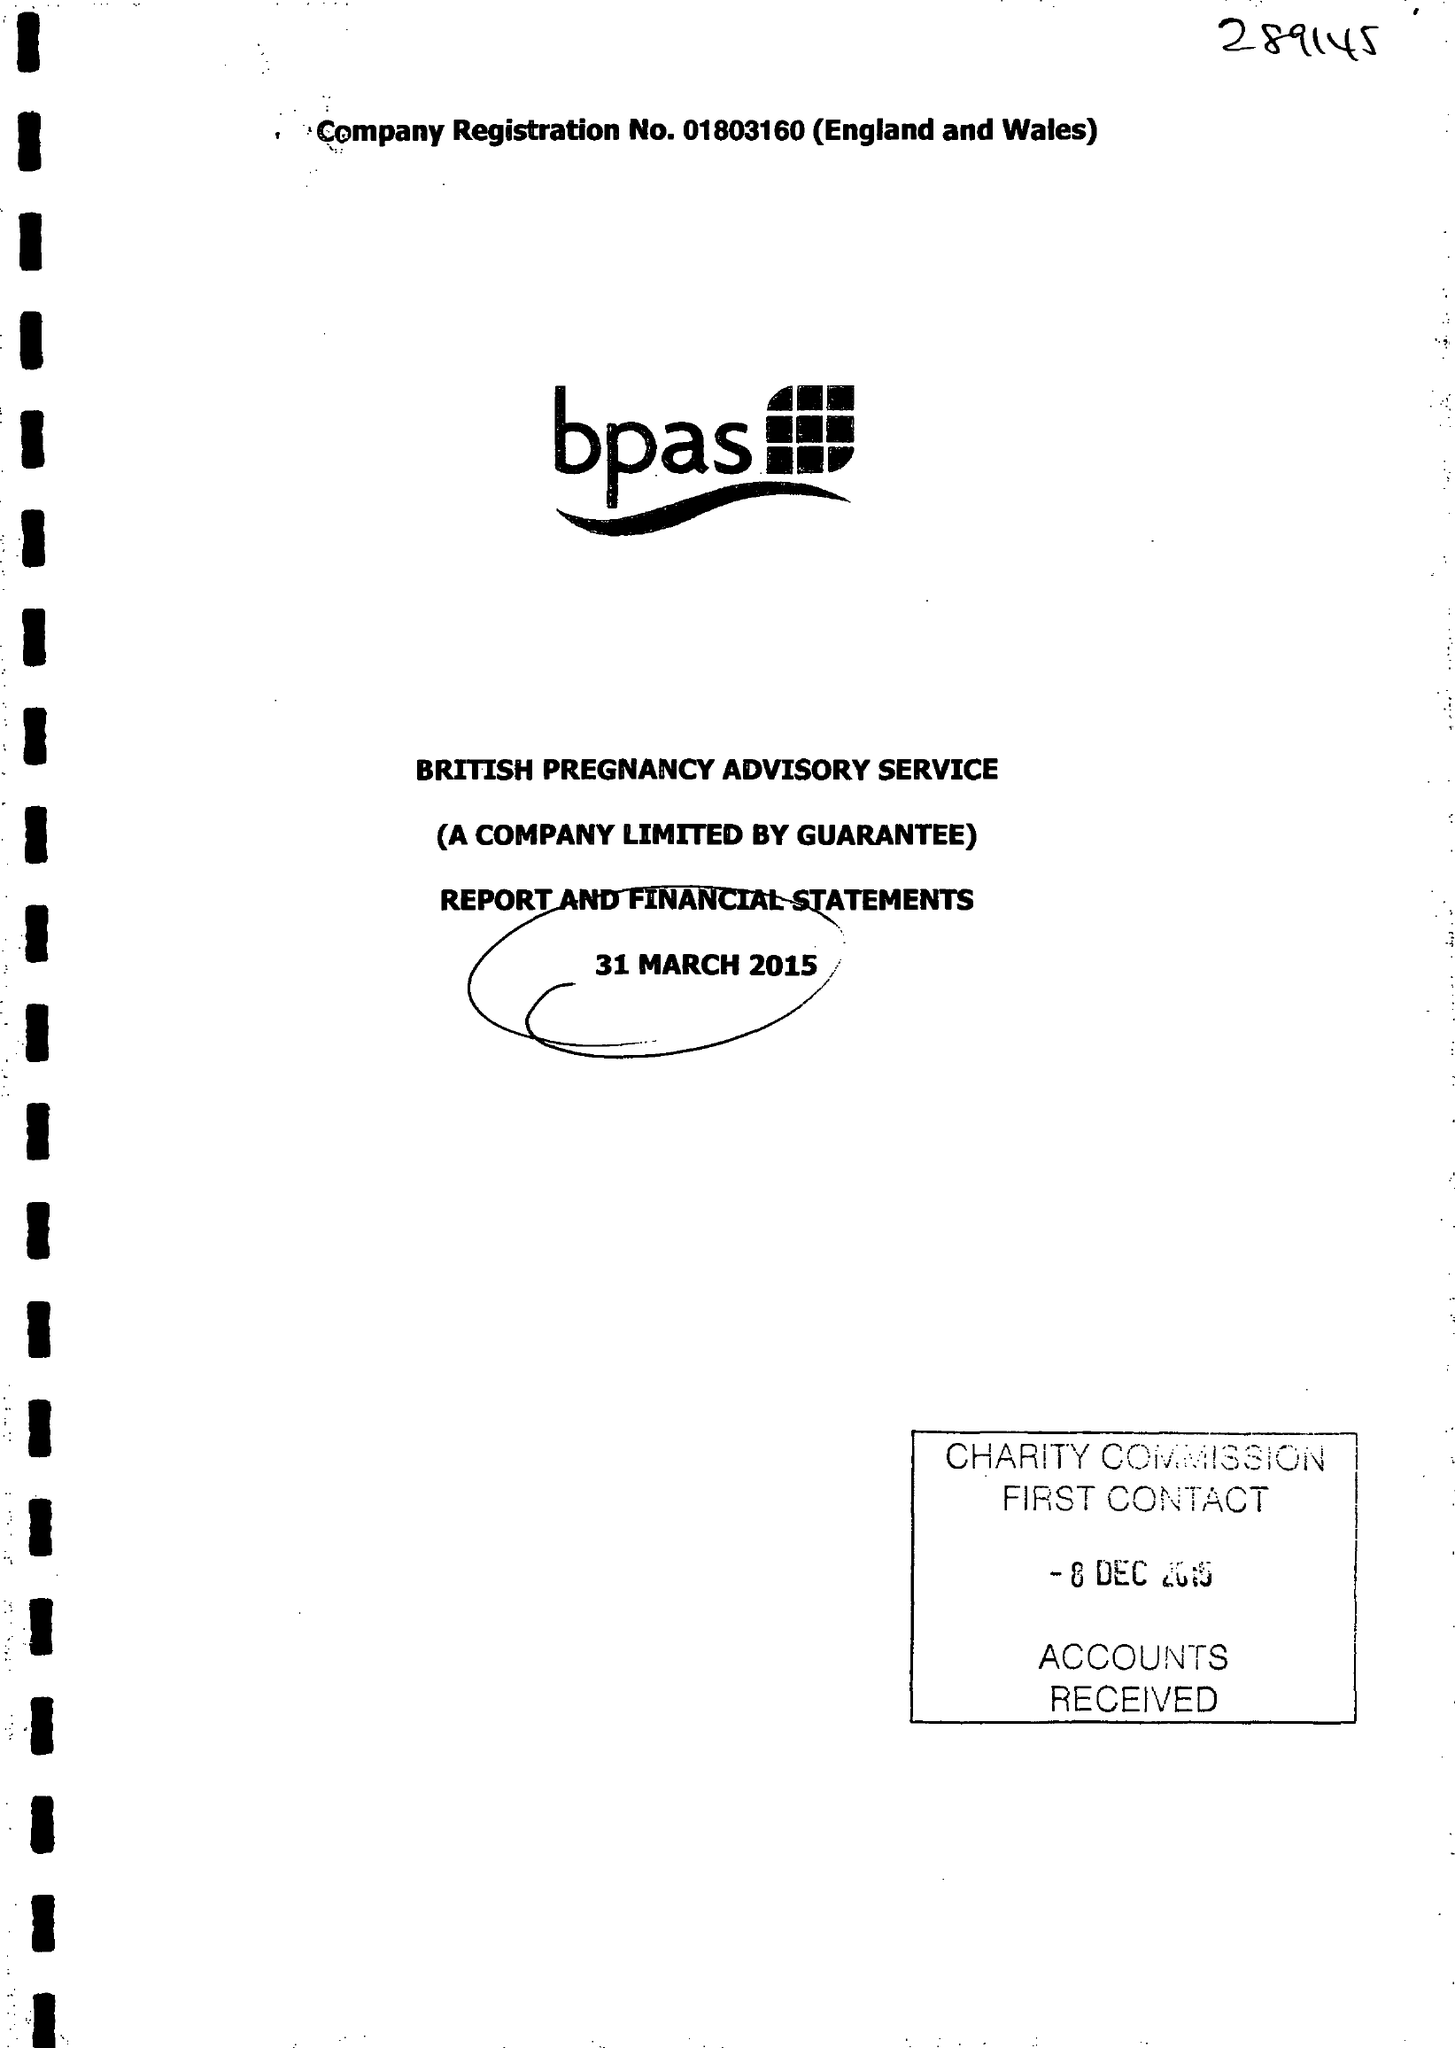What is the value for the spending_annually_in_british_pounds?
Answer the question using a single word or phrase. 28514000.00 